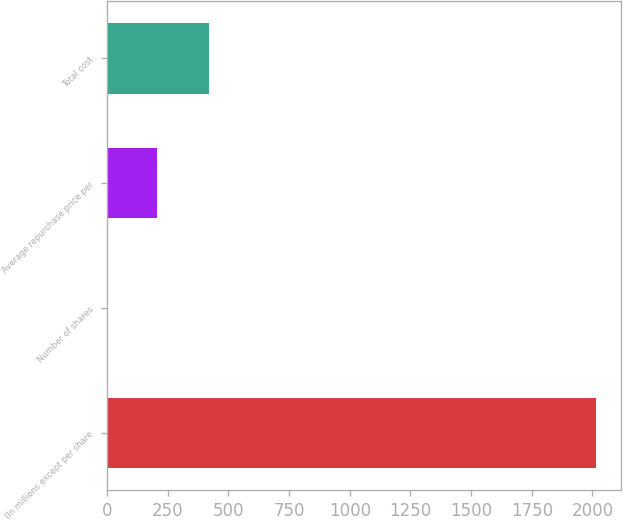Convert chart. <chart><loc_0><loc_0><loc_500><loc_500><bar_chart><fcel>(In millions except per share<fcel>Number of shares<fcel>Average repurchase price per<fcel>Total cost<nl><fcel>2015<fcel>4.8<fcel>205.82<fcel>422<nl></chart> 